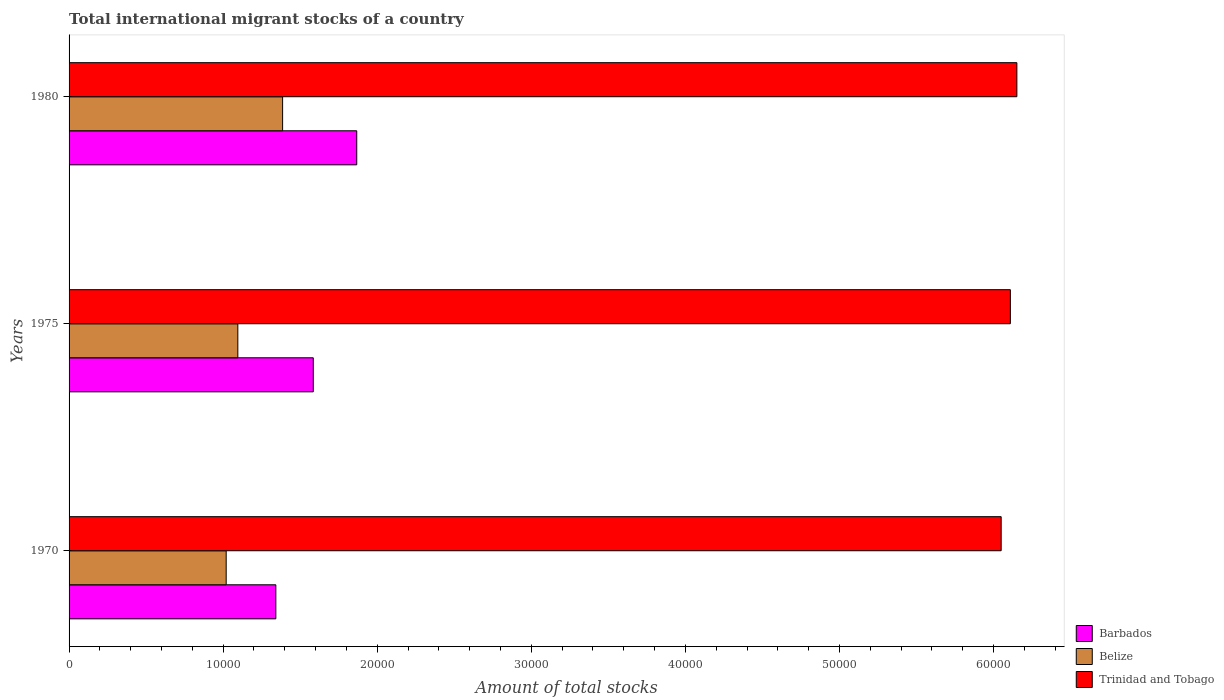How many groups of bars are there?
Make the answer very short. 3. Are the number of bars per tick equal to the number of legend labels?
Offer a very short reply. Yes. What is the label of the 1st group of bars from the top?
Your answer should be very brief. 1980. In how many cases, is the number of bars for a given year not equal to the number of legend labels?
Your response must be concise. 0. What is the amount of total stocks in in Trinidad and Tobago in 1980?
Your answer should be compact. 6.15e+04. Across all years, what is the maximum amount of total stocks in in Barbados?
Offer a very short reply. 1.87e+04. Across all years, what is the minimum amount of total stocks in in Barbados?
Offer a very short reply. 1.34e+04. In which year was the amount of total stocks in in Barbados minimum?
Ensure brevity in your answer.  1970. What is the total amount of total stocks in in Belize in the graph?
Offer a terse response. 3.50e+04. What is the difference between the amount of total stocks in in Belize in 1975 and that in 1980?
Make the answer very short. -2906. What is the difference between the amount of total stocks in in Trinidad and Tobago in 1970 and the amount of total stocks in in Belize in 1975?
Offer a very short reply. 4.95e+04. What is the average amount of total stocks in in Trinidad and Tobago per year?
Offer a very short reply. 6.10e+04. In the year 1980, what is the difference between the amount of total stocks in in Barbados and amount of total stocks in in Belize?
Your answer should be compact. 4812. In how many years, is the amount of total stocks in in Barbados greater than 48000 ?
Ensure brevity in your answer.  0. What is the ratio of the amount of total stocks in in Belize in 1970 to that in 1980?
Provide a short and direct response. 0.74. Is the amount of total stocks in in Belize in 1970 less than that in 1975?
Your answer should be very brief. Yes. What is the difference between the highest and the second highest amount of total stocks in in Belize?
Provide a succinct answer. 2906. What is the difference between the highest and the lowest amount of total stocks in in Barbados?
Give a very brief answer. 5251. In how many years, is the amount of total stocks in in Barbados greater than the average amount of total stocks in in Barbados taken over all years?
Ensure brevity in your answer.  1. Is the sum of the amount of total stocks in in Barbados in 1975 and 1980 greater than the maximum amount of total stocks in in Belize across all years?
Give a very brief answer. Yes. What does the 3rd bar from the top in 1970 represents?
Give a very brief answer. Barbados. What does the 2nd bar from the bottom in 1980 represents?
Your answer should be compact. Belize. What is the difference between two consecutive major ticks on the X-axis?
Your answer should be compact. 10000. How are the legend labels stacked?
Offer a terse response. Vertical. What is the title of the graph?
Your answer should be very brief. Total international migrant stocks of a country. What is the label or title of the X-axis?
Your answer should be compact. Amount of total stocks. What is the label or title of the Y-axis?
Keep it short and to the point. Years. What is the Amount of total stocks of Barbados in 1970?
Offer a terse response. 1.34e+04. What is the Amount of total stocks in Belize in 1970?
Offer a very short reply. 1.02e+04. What is the Amount of total stocks of Trinidad and Tobago in 1970?
Your response must be concise. 6.05e+04. What is the Amount of total stocks of Barbados in 1975?
Give a very brief answer. 1.58e+04. What is the Amount of total stocks in Belize in 1975?
Give a very brief answer. 1.10e+04. What is the Amount of total stocks of Trinidad and Tobago in 1975?
Offer a very short reply. 6.11e+04. What is the Amount of total stocks of Barbados in 1980?
Offer a very short reply. 1.87e+04. What is the Amount of total stocks of Belize in 1980?
Keep it short and to the point. 1.39e+04. What is the Amount of total stocks of Trinidad and Tobago in 1980?
Offer a very short reply. 6.15e+04. Across all years, what is the maximum Amount of total stocks in Barbados?
Keep it short and to the point. 1.87e+04. Across all years, what is the maximum Amount of total stocks of Belize?
Make the answer very short. 1.39e+04. Across all years, what is the maximum Amount of total stocks of Trinidad and Tobago?
Keep it short and to the point. 6.15e+04. Across all years, what is the minimum Amount of total stocks of Barbados?
Offer a terse response. 1.34e+04. Across all years, what is the minimum Amount of total stocks of Belize?
Provide a short and direct response. 1.02e+04. Across all years, what is the minimum Amount of total stocks of Trinidad and Tobago?
Offer a very short reply. 6.05e+04. What is the total Amount of total stocks in Barbados in the graph?
Give a very brief answer. 4.79e+04. What is the total Amount of total stocks in Belize in the graph?
Keep it short and to the point. 3.50e+04. What is the total Amount of total stocks of Trinidad and Tobago in the graph?
Offer a terse response. 1.83e+05. What is the difference between the Amount of total stocks of Barbados in 1970 and that in 1975?
Keep it short and to the point. -2430. What is the difference between the Amount of total stocks in Belize in 1970 and that in 1975?
Your response must be concise. -756. What is the difference between the Amount of total stocks of Trinidad and Tobago in 1970 and that in 1975?
Keep it short and to the point. -597. What is the difference between the Amount of total stocks in Barbados in 1970 and that in 1980?
Offer a very short reply. -5251. What is the difference between the Amount of total stocks of Belize in 1970 and that in 1980?
Provide a short and direct response. -3662. What is the difference between the Amount of total stocks in Trinidad and Tobago in 1970 and that in 1980?
Offer a very short reply. -1019. What is the difference between the Amount of total stocks in Barbados in 1975 and that in 1980?
Your response must be concise. -2821. What is the difference between the Amount of total stocks in Belize in 1975 and that in 1980?
Give a very brief answer. -2906. What is the difference between the Amount of total stocks in Trinidad and Tobago in 1975 and that in 1980?
Offer a terse response. -422. What is the difference between the Amount of total stocks of Barbados in 1970 and the Amount of total stocks of Belize in 1975?
Keep it short and to the point. 2467. What is the difference between the Amount of total stocks of Barbados in 1970 and the Amount of total stocks of Trinidad and Tobago in 1975?
Provide a short and direct response. -4.77e+04. What is the difference between the Amount of total stocks of Belize in 1970 and the Amount of total stocks of Trinidad and Tobago in 1975?
Make the answer very short. -5.09e+04. What is the difference between the Amount of total stocks of Barbados in 1970 and the Amount of total stocks of Belize in 1980?
Keep it short and to the point. -439. What is the difference between the Amount of total stocks of Barbados in 1970 and the Amount of total stocks of Trinidad and Tobago in 1980?
Give a very brief answer. -4.81e+04. What is the difference between the Amount of total stocks of Belize in 1970 and the Amount of total stocks of Trinidad and Tobago in 1980?
Make the answer very short. -5.13e+04. What is the difference between the Amount of total stocks of Barbados in 1975 and the Amount of total stocks of Belize in 1980?
Ensure brevity in your answer.  1991. What is the difference between the Amount of total stocks in Barbados in 1975 and the Amount of total stocks in Trinidad and Tobago in 1980?
Your answer should be very brief. -4.57e+04. What is the difference between the Amount of total stocks of Belize in 1975 and the Amount of total stocks of Trinidad and Tobago in 1980?
Make the answer very short. -5.06e+04. What is the average Amount of total stocks of Barbados per year?
Ensure brevity in your answer.  1.60e+04. What is the average Amount of total stocks of Belize per year?
Offer a very short reply. 1.17e+04. What is the average Amount of total stocks in Trinidad and Tobago per year?
Give a very brief answer. 6.10e+04. In the year 1970, what is the difference between the Amount of total stocks in Barbados and Amount of total stocks in Belize?
Ensure brevity in your answer.  3223. In the year 1970, what is the difference between the Amount of total stocks in Barbados and Amount of total stocks in Trinidad and Tobago?
Offer a very short reply. -4.71e+04. In the year 1970, what is the difference between the Amount of total stocks in Belize and Amount of total stocks in Trinidad and Tobago?
Provide a succinct answer. -5.03e+04. In the year 1975, what is the difference between the Amount of total stocks of Barbados and Amount of total stocks of Belize?
Ensure brevity in your answer.  4897. In the year 1975, what is the difference between the Amount of total stocks of Barbados and Amount of total stocks of Trinidad and Tobago?
Make the answer very short. -4.52e+04. In the year 1975, what is the difference between the Amount of total stocks in Belize and Amount of total stocks in Trinidad and Tobago?
Make the answer very short. -5.01e+04. In the year 1980, what is the difference between the Amount of total stocks of Barbados and Amount of total stocks of Belize?
Your answer should be very brief. 4812. In the year 1980, what is the difference between the Amount of total stocks in Barbados and Amount of total stocks in Trinidad and Tobago?
Offer a very short reply. -4.28e+04. In the year 1980, what is the difference between the Amount of total stocks of Belize and Amount of total stocks of Trinidad and Tobago?
Make the answer very short. -4.77e+04. What is the ratio of the Amount of total stocks in Barbados in 1970 to that in 1975?
Your response must be concise. 0.85. What is the ratio of the Amount of total stocks of Trinidad and Tobago in 1970 to that in 1975?
Ensure brevity in your answer.  0.99. What is the ratio of the Amount of total stocks of Barbados in 1970 to that in 1980?
Your answer should be very brief. 0.72. What is the ratio of the Amount of total stocks in Belize in 1970 to that in 1980?
Give a very brief answer. 0.74. What is the ratio of the Amount of total stocks of Trinidad and Tobago in 1970 to that in 1980?
Your answer should be compact. 0.98. What is the ratio of the Amount of total stocks of Barbados in 1975 to that in 1980?
Offer a very short reply. 0.85. What is the ratio of the Amount of total stocks in Belize in 1975 to that in 1980?
Ensure brevity in your answer.  0.79. What is the ratio of the Amount of total stocks in Trinidad and Tobago in 1975 to that in 1980?
Your answer should be compact. 0.99. What is the difference between the highest and the second highest Amount of total stocks of Barbados?
Provide a short and direct response. 2821. What is the difference between the highest and the second highest Amount of total stocks in Belize?
Your answer should be compact. 2906. What is the difference between the highest and the second highest Amount of total stocks in Trinidad and Tobago?
Provide a succinct answer. 422. What is the difference between the highest and the lowest Amount of total stocks of Barbados?
Your response must be concise. 5251. What is the difference between the highest and the lowest Amount of total stocks of Belize?
Offer a terse response. 3662. What is the difference between the highest and the lowest Amount of total stocks of Trinidad and Tobago?
Provide a short and direct response. 1019. 